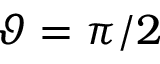Convert formula to latex. <formula><loc_0><loc_0><loc_500><loc_500>\vartheta = \pi / 2</formula> 